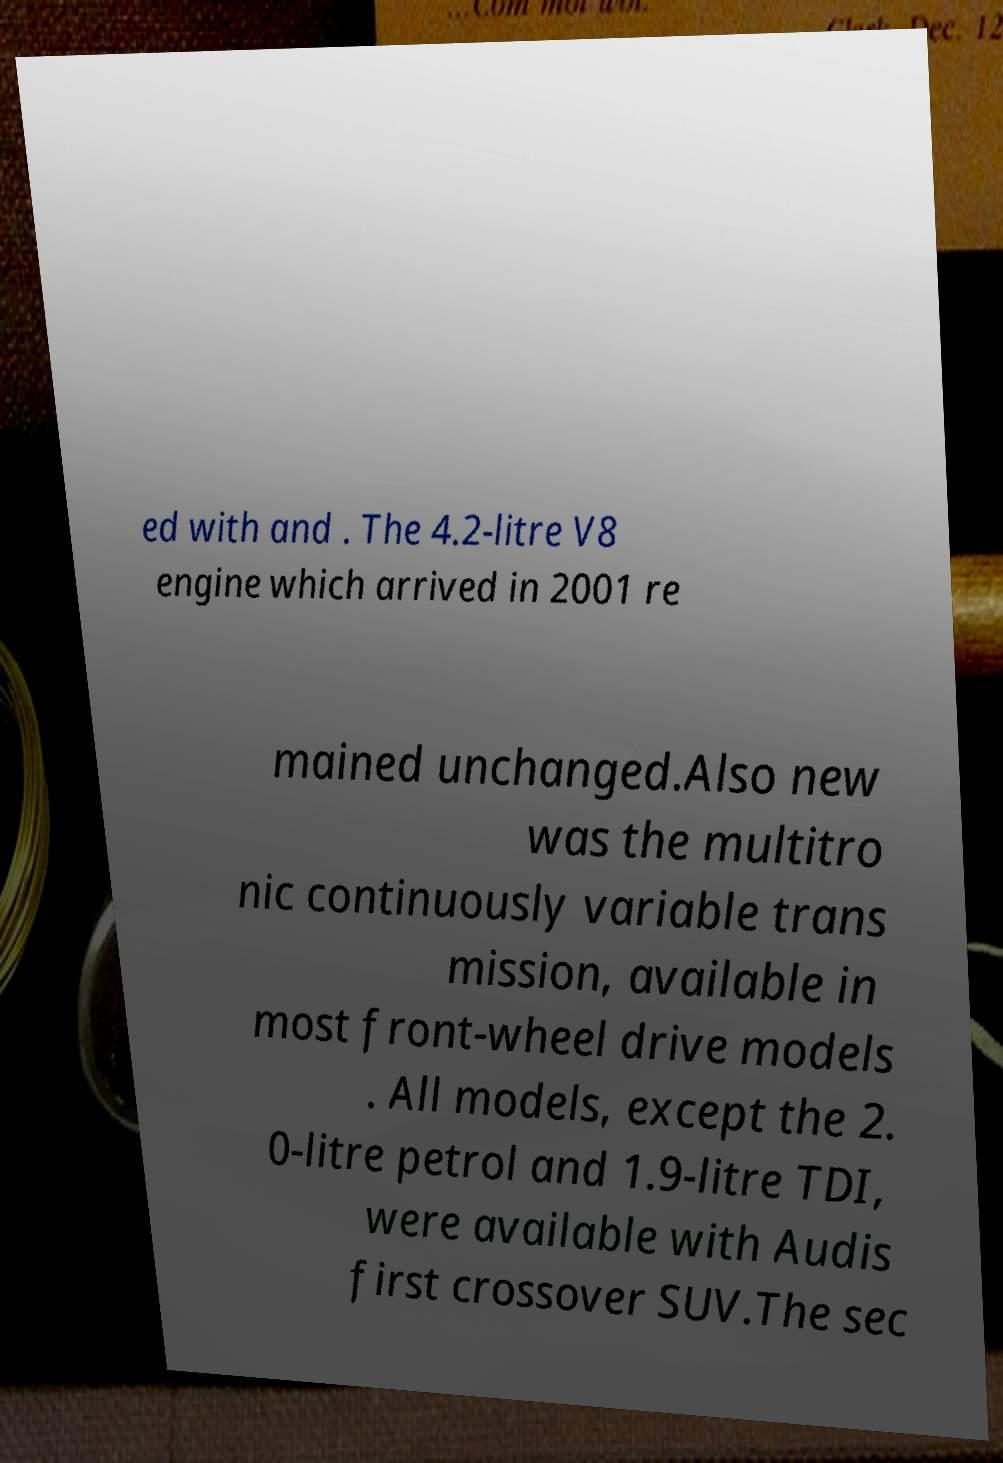Could you extract and type out the text from this image? ed with and . The 4.2-litre V8 engine which arrived in 2001 re mained unchanged.Also new was the multitro nic continuously variable trans mission, available in most front-wheel drive models . All models, except the 2. 0-litre petrol and 1.9-litre TDI, were available with Audis first crossover SUV.The sec 